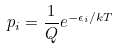Convert formula to latex. <formula><loc_0><loc_0><loc_500><loc_500>p _ { i } = \frac { 1 } { Q } e ^ { - \epsilon _ { i } / k T }</formula> 